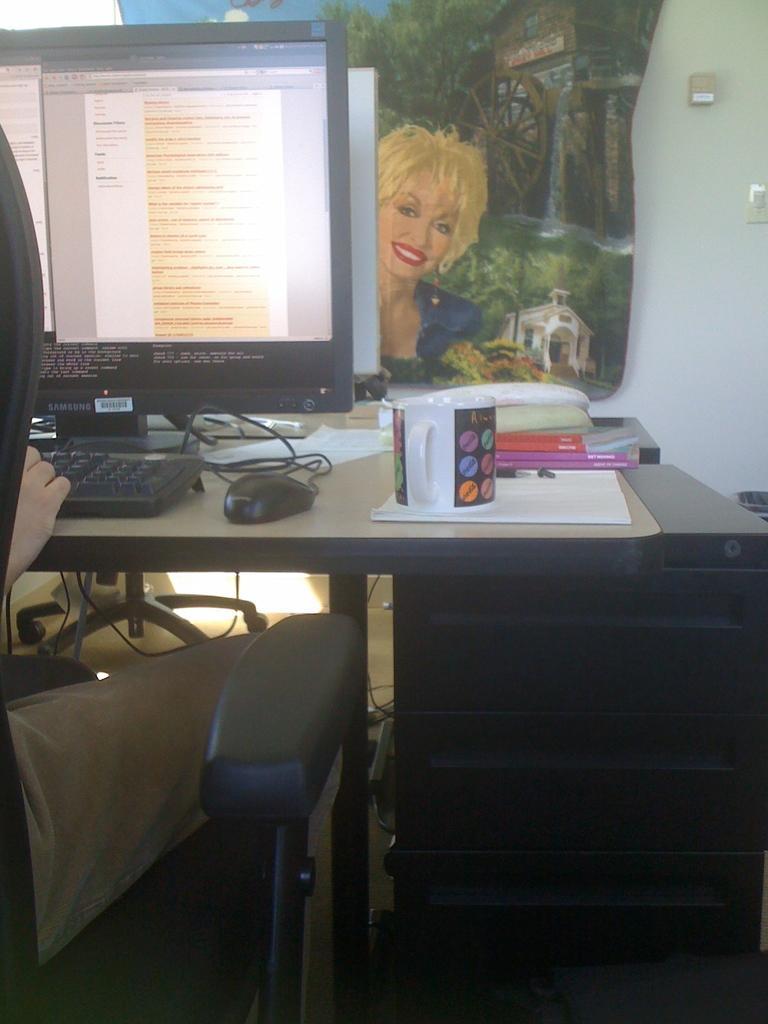How would you summarize this image in a sentence or two? In this image I see a person who is sitting on a chair and I see a table on which there is a monitor, keyboard, a mouse and a cup and other things and in the background I see the white wall on which there is a photo frame of a woman who is smiling and I can also see few wires. 